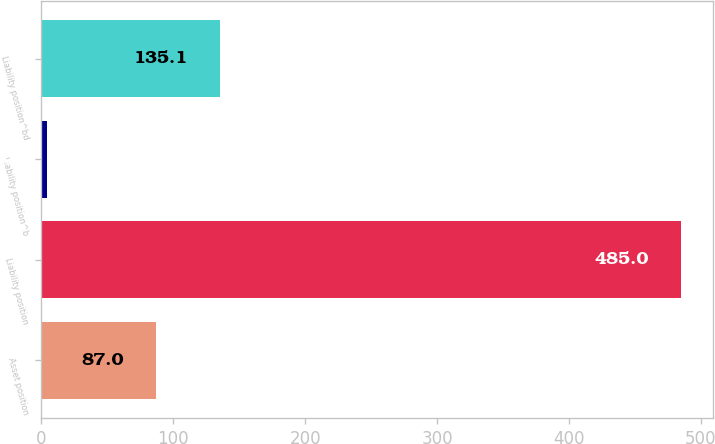Convert chart to OTSL. <chart><loc_0><loc_0><loc_500><loc_500><bar_chart><fcel>Asset position<fcel>Liability position<fcel>Liability position^b<fcel>Liability position^bd<nl><fcel>87<fcel>485<fcel>4<fcel>135.1<nl></chart> 